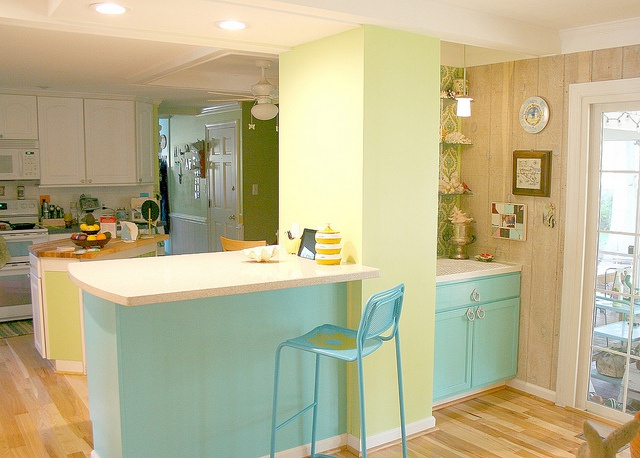Describe the objects in this image and their specific colors. I can see chair in tan, teal, darkgray, lightblue, and olive tones, oven in tan, gray, and darkgray tones, microwave in tan, gray, and darkgray tones, vase in tan and olive tones, and clock in tan and darkgray tones in this image. 